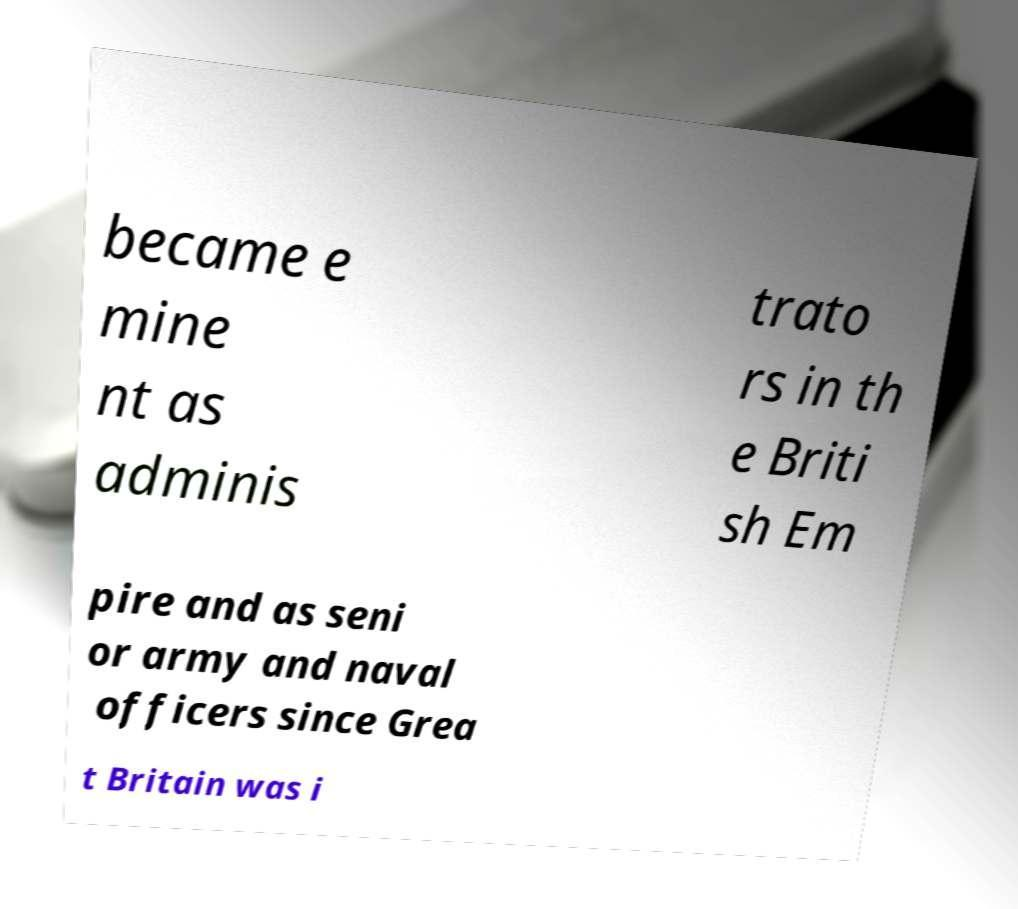For documentation purposes, I need the text within this image transcribed. Could you provide that? became e mine nt as adminis trato rs in th e Briti sh Em pire and as seni or army and naval officers since Grea t Britain was i 